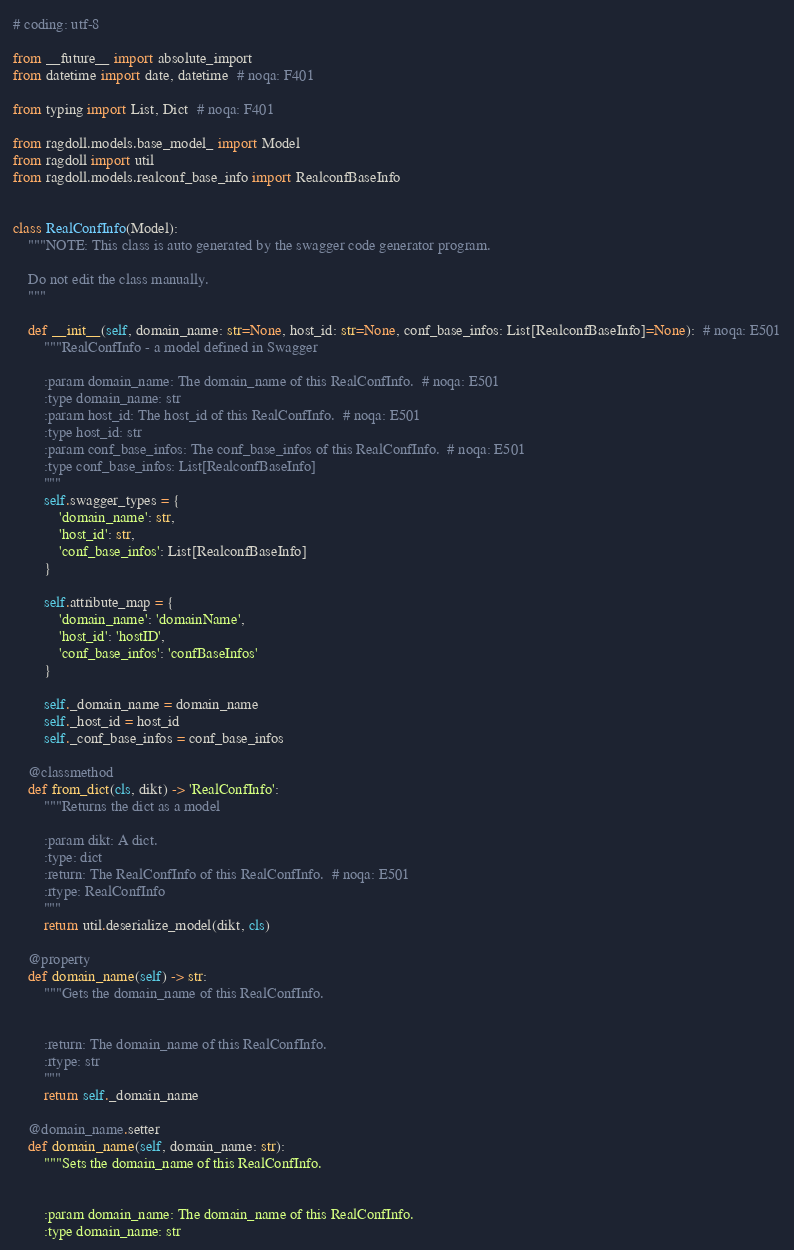<code> <loc_0><loc_0><loc_500><loc_500><_Python_># coding: utf-8

from __future__ import absolute_import
from datetime import date, datetime  # noqa: F401

from typing import List, Dict  # noqa: F401

from ragdoll.models.base_model_ import Model
from ragdoll import util
from ragdoll.models.realconf_base_info import RealconfBaseInfo


class RealConfInfo(Model):
    """NOTE: This class is auto generated by the swagger code generator program.

    Do not edit the class manually.
    """

    def __init__(self, domain_name: str=None, host_id: str=None, conf_base_infos: List[RealconfBaseInfo]=None):  # noqa: E501
        """RealConfInfo - a model defined in Swagger

        :param domain_name: The domain_name of this RealConfInfo.  # noqa: E501
        :type domain_name: str
        :param host_id: The host_id of this RealConfInfo.  # noqa: E501
        :type host_id: str
        :param conf_base_infos: The conf_base_infos of this RealConfInfo.  # noqa: E501
        :type conf_base_infos: List[RealconfBaseInfo]
        """
        self.swagger_types = {
            'domain_name': str,
            'host_id': str,
            'conf_base_infos': List[RealconfBaseInfo]
        }

        self.attribute_map = {
            'domain_name': 'domainName',
            'host_id': 'hostID',
            'conf_base_infos': 'confBaseInfos'
        }

        self._domain_name = domain_name
        self._host_id = host_id
        self._conf_base_infos = conf_base_infos

    @classmethod
    def from_dict(cls, dikt) -> 'RealConfInfo':
        """Returns the dict as a model

        :param dikt: A dict.
        :type: dict
        :return: The RealConfInfo of this RealConfInfo.  # noqa: E501
        :rtype: RealConfInfo
        """
        return util.deserialize_model(dikt, cls)

    @property
    def domain_name(self) -> str:
        """Gets the domain_name of this RealConfInfo.


        :return: The domain_name of this RealConfInfo.
        :rtype: str
        """
        return self._domain_name

    @domain_name.setter
    def domain_name(self, domain_name: str):
        """Sets the domain_name of this RealConfInfo.


        :param domain_name: The domain_name of this RealConfInfo.
        :type domain_name: str</code> 